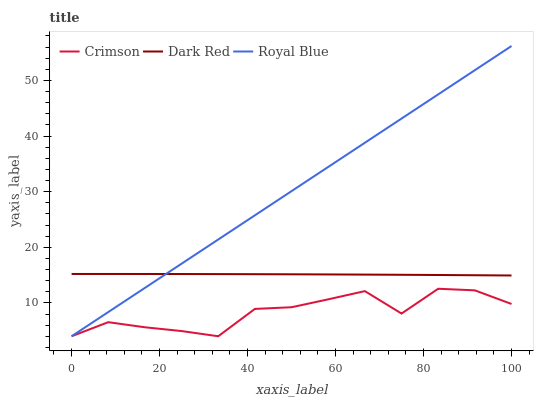Does Crimson have the minimum area under the curve?
Answer yes or no. Yes. Does Royal Blue have the maximum area under the curve?
Answer yes or no. Yes. Does Dark Red have the minimum area under the curve?
Answer yes or no. No. Does Dark Red have the maximum area under the curve?
Answer yes or no. No. Is Royal Blue the smoothest?
Answer yes or no. Yes. Is Crimson the roughest?
Answer yes or no. Yes. Is Dark Red the smoothest?
Answer yes or no. No. Is Dark Red the roughest?
Answer yes or no. No. Does Crimson have the lowest value?
Answer yes or no. Yes. Does Dark Red have the lowest value?
Answer yes or no. No. Does Royal Blue have the highest value?
Answer yes or no. Yes. Does Dark Red have the highest value?
Answer yes or no. No. Is Crimson less than Dark Red?
Answer yes or no. Yes. Is Dark Red greater than Crimson?
Answer yes or no. Yes. Does Crimson intersect Royal Blue?
Answer yes or no. Yes. Is Crimson less than Royal Blue?
Answer yes or no. No. Is Crimson greater than Royal Blue?
Answer yes or no. No. Does Crimson intersect Dark Red?
Answer yes or no. No. 